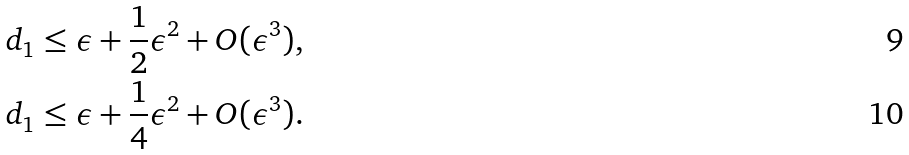Convert formula to latex. <formula><loc_0><loc_0><loc_500><loc_500>d _ { 1 } & \leq \epsilon + \frac { 1 } { 2 } \epsilon ^ { 2 } + O ( \epsilon ^ { 3 } ) , \\ d _ { 1 } & \leq \epsilon + \frac { 1 } { 4 } \epsilon ^ { 2 } + O ( \epsilon ^ { 3 } ) .</formula> 